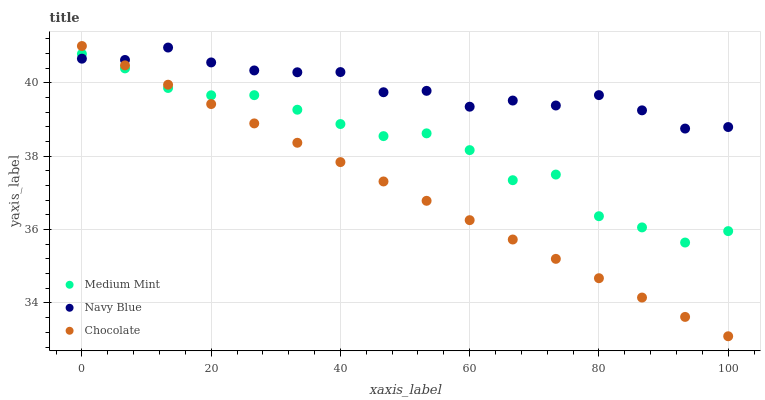Does Chocolate have the minimum area under the curve?
Answer yes or no. Yes. Does Navy Blue have the maximum area under the curve?
Answer yes or no. Yes. Does Navy Blue have the minimum area under the curve?
Answer yes or no. No. Does Chocolate have the maximum area under the curve?
Answer yes or no. No. Is Chocolate the smoothest?
Answer yes or no. Yes. Is Medium Mint the roughest?
Answer yes or no. Yes. Is Navy Blue the smoothest?
Answer yes or no. No. Is Navy Blue the roughest?
Answer yes or no. No. Does Chocolate have the lowest value?
Answer yes or no. Yes. Does Navy Blue have the lowest value?
Answer yes or no. No. Does Chocolate have the highest value?
Answer yes or no. Yes. Does Navy Blue have the highest value?
Answer yes or no. No. Does Navy Blue intersect Medium Mint?
Answer yes or no. Yes. Is Navy Blue less than Medium Mint?
Answer yes or no. No. Is Navy Blue greater than Medium Mint?
Answer yes or no. No. 